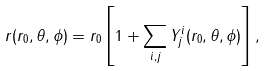<formula> <loc_0><loc_0><loc_500><loc_500>r ( r _ { 0 } , \theta , \phi ) = r _ { 0 } \left [ 1 + \sum _ { i , j } Y ^ { i } _ { j } ( r _ { 0 } , \theta , \phi ) \right ] ,</formula> 